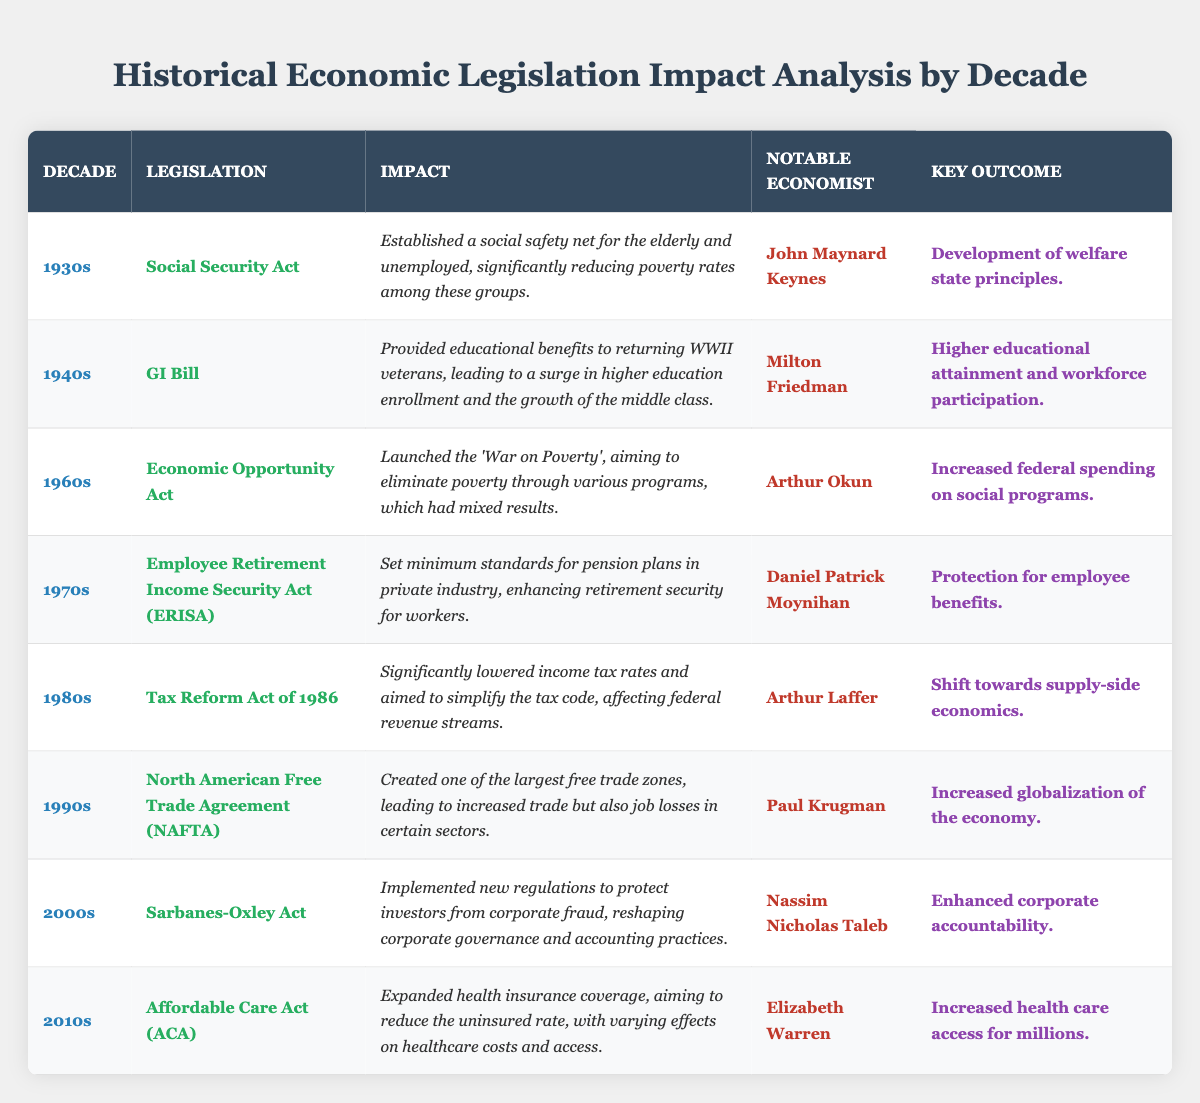What legislation was passed in the 1940s? The table lists the legislation by decade, and for the 1940s, it shows the GI Bill.
Answer: GI Bill Who is the notable economist associated with the Social Security Act? According to the table, the notable economist linked to the Social Security Act is John Maynard Keynes.
Answer: John Maynard Keynes What impact did the Affordable Care Act have? The table states that the Affordable Care Act expanded health insurance coverage, aiming to reduce the uninsured rate.
Answer: Expanded health insurance coverage In which decade did the Employee Retirement Income Security Act (ERISA) introduce enhanced retirement security? By looking at the table, ERISA is associated with the 1970s decade.
Answer: 1970s Which legislation is noted for increasing globalization in the economy during the 1990s? The table indicates that the North American Free Trade Agreement (NAFTA) created one of the largest free trade zones, leading to increased globalization.
Answer: North American Free Trade Agreement (NAFTA) What was the key outcome of the Economic Opportunity Act? The table specifies that the key outcome of the Economic Opportunity Act was increased federal spending on social programs.
Answer: Increased federal spending on social programs How many pieces of legislation are mentioned for the 1980s and what are they? The table shows that there is one piece of legislation mentioned for the 1980s, which is the Tax Reform Act of 1986.
Answer: One; Tax Reform Act of 1986 Is the Sarbanes-Oxley Act associated with the 2000s? The table notes the Sarbanes-Oxley Act in the 2000s, confirming its association with that decade.
Answer: Yes What change did the Tax Reform Act of 1986 emphasize in the economic policy? From the table, it shows that the Tax Reform Act of 1986 emphasized a shift towards supply-side economics.
Answer: Shift towards supply-side economics Which legislation is linked to the concept of a welfare state? The table indicates that the Social Security Act is linked to the development of welfare state principles.
Answer: Social Security Act What was the notable economist's view on the GI Bill? The GI Bill is associated with Milton Friedman, although the table does not provide specific views, we can deduce its importance to economic recovery after WWII.
Answer: Milton Friedman What decade focused on eliminating poverty through various programs? According to the table, the 1960s with the Economic Opportunity Act focused on eliminating poverty through various programs.
Answer: 1960s How did the GI Bill affect higher education enrollment? The table states that the GI Bill led to a surge in higher education enrollment, contributing to the growth of the middle class.
Answer: Surge in higher education enrollment Which legislation is noted for reshaping corporate governance? The Sarbanes-Oxley Act is the legislation noted for implementing new regulations to protect investors from corporate fraud, thus reshaping corporate governance.
Answer: Sarbanes-Oxley Act What impact did the Employee Retirement Income Security Act (ERISA) have on workers? The table describes the impact of ERISA as setting minimum standards for pension plans, enhancing retirement security for workers.
Answer: Enhanced retirement security for workers How did the Economic Opportunity Act affect federal spending? The table mentions that the Economic Opportunity Act led to increased federal spending on various social programs aimed at poverty elimination.
Answer: Increased federal spending on social programs 